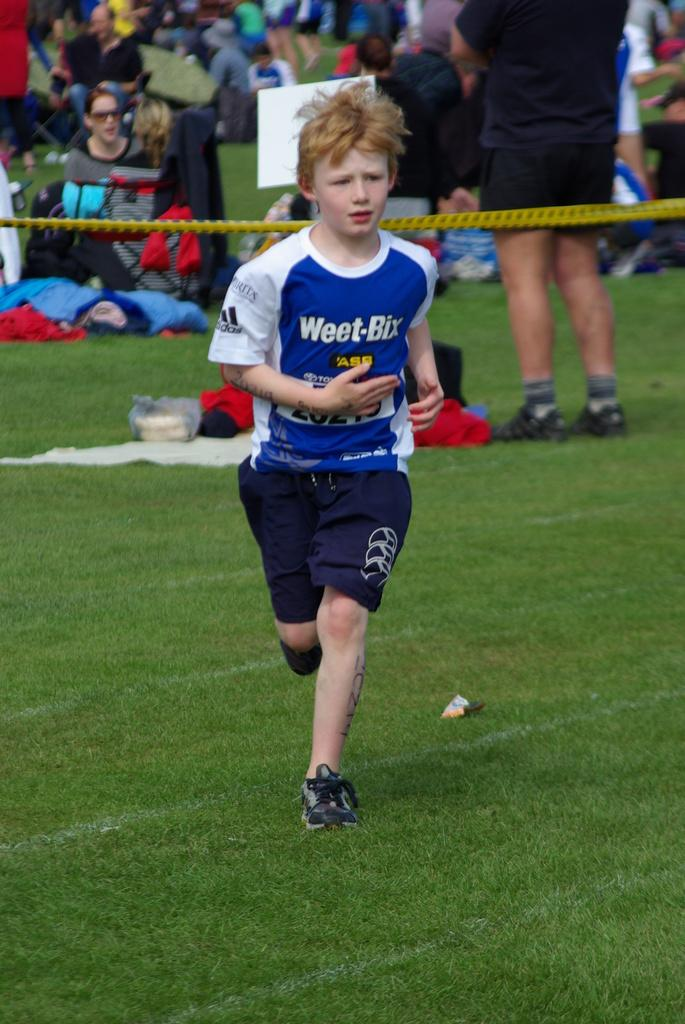Can you describe the person in the background of the image? There is a person wearing a black dress in the background of the image. What are the people in the image doing? There is a group of people sitting on the ground in the image. What type of insect can be seen crawling on the peace symbol in the image? There is no insect or peace symbol present in the image. What is the person in the black dress holding in the image? The provided facts do not mention anything the person in the black dress might be holding. 